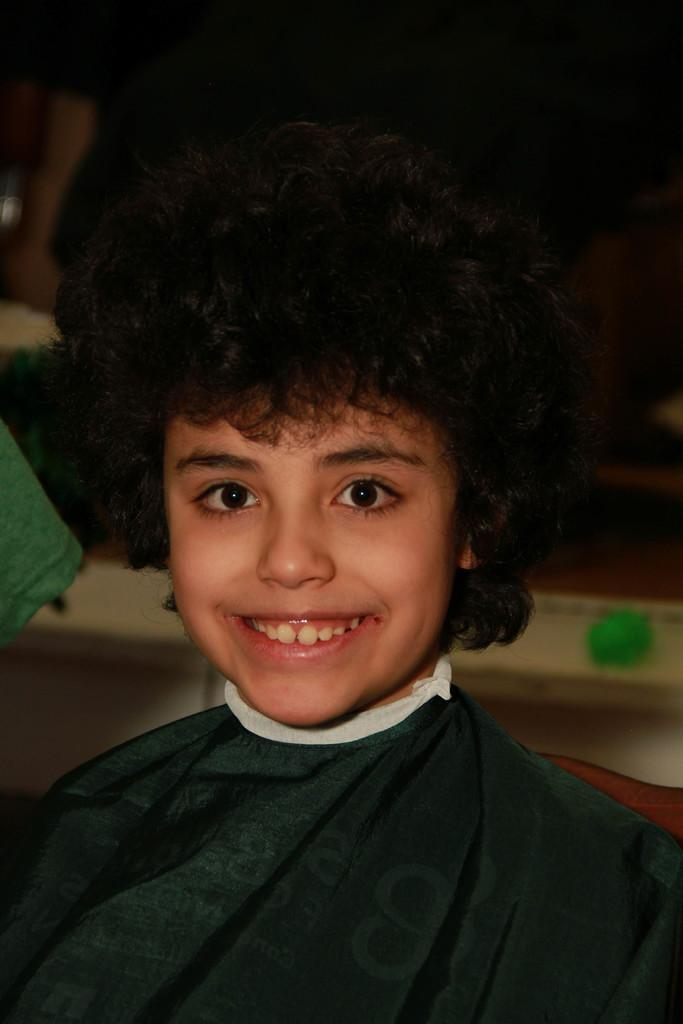What is the main subject of the image? There is a child in the image. What is the child doing in the image? The child is watching and smiling. Can you describe the background of the image? The background of the image has a blurred view. What color is the cloth on the left side of the image? There is a green cloth on the left side of the image. What type of map can be seen in the child's hand in the image? There is no map present in the image; the child is simply watching and smiling. What subject is the child learning about in the image? There is no indication in the image that the child is learning about any specific subject. 